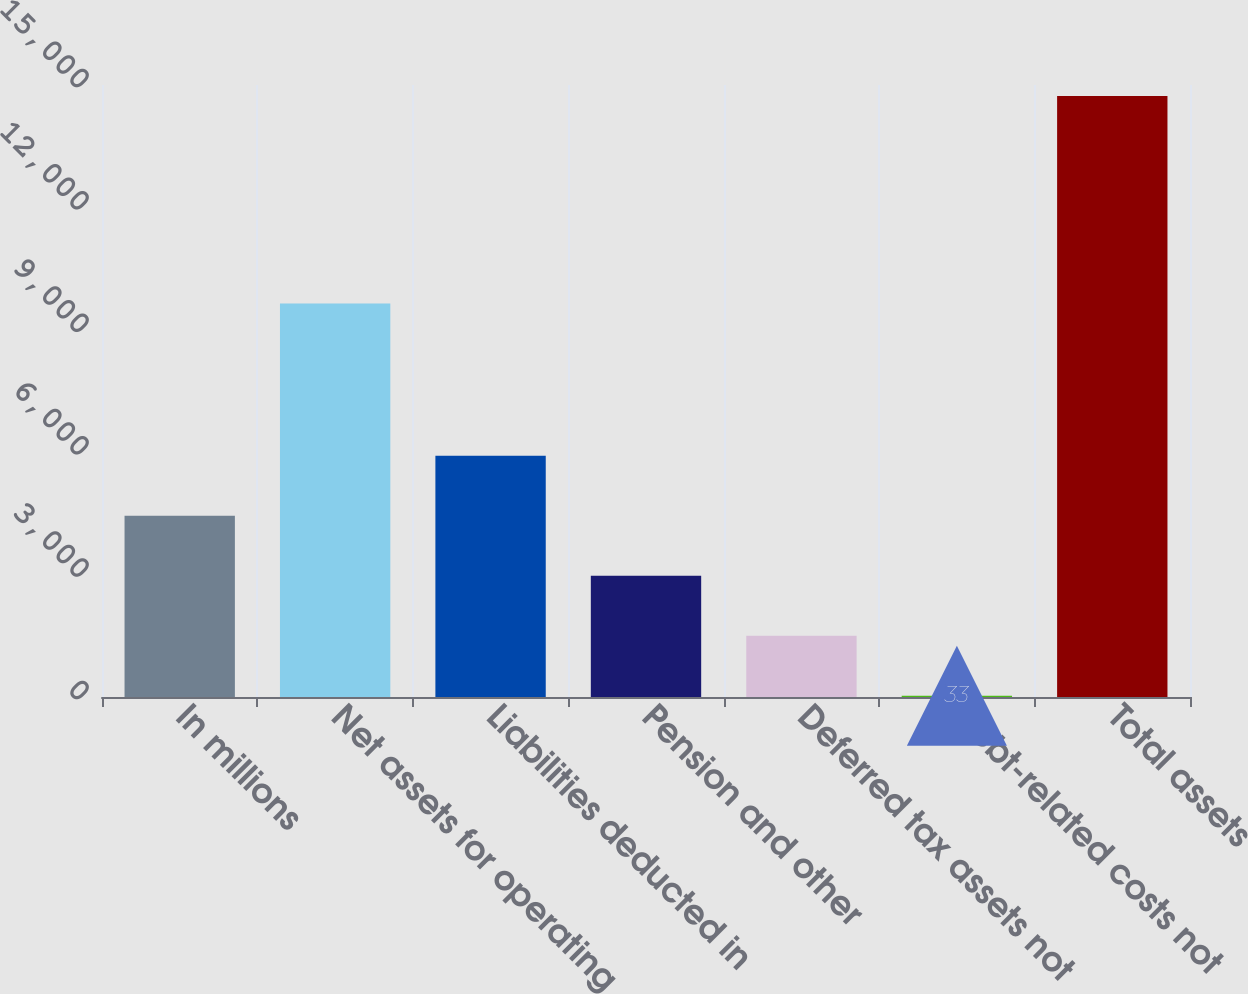Convert chart to OTSL. <chart><loc_0><loc_0><loc_500><loc_500><bar_chart><fcel>In millions<fcel>Net assets for operating<fcel>Liabilities deducted in<fcel>Pension and other<fcel>Deferred tax assets not<fcel>Debt-related costs not<fcel>Total assets<nl><fcel>4441.5<fcel>9646<fcel>5911<fcel>2972<fcel>1502.5<fcel>33<fcel>14728<nl></chart> 